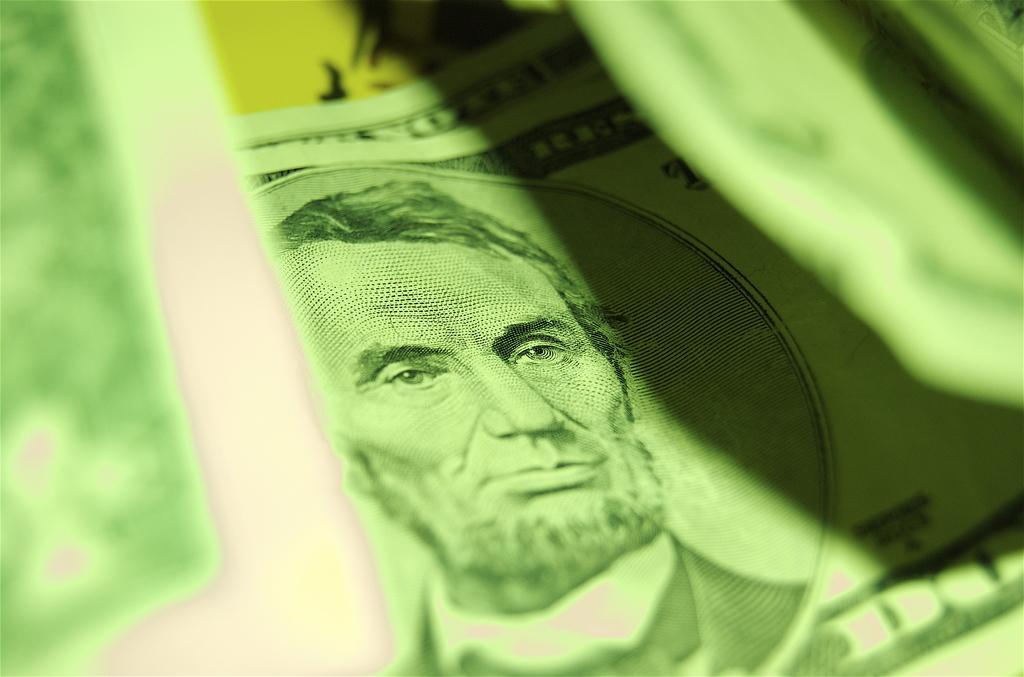Describe this image in one or two sentences. In this picture, we can see papers. On that paper, we can see painting of a person which is in green color. In the background, we can also see yellow color. 